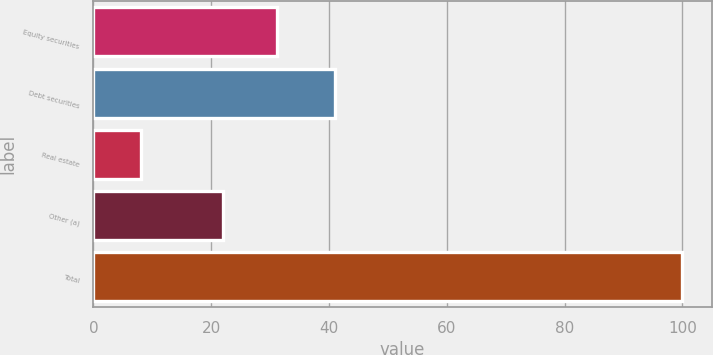<chart> <loc_0><loc_0><loc_500><loc_500><bar_chart><fcel>Equity securities<fcel>Debt securities<fcel>Real estate<fcel>Other (a)<fcel>Total<nl><fcel>31.2<fcel>41<fcel>8<fcel>22<fcel>100<nl></chart> 